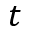<formula> <loc_0><loc_0><loc_500><loc_500>t</formula> 